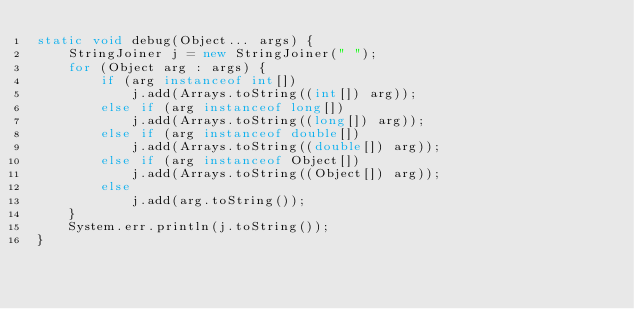Convert code to text. <code><loc_0><loc_0><loc_500><loc_500><_Java_>static void debug(Object... args) {
    StringJoiner j = new StringJoiner(" ");
    for (Object arg : args) {
        if (arg instanceof int[])
            j.add(Arrays.toString((int[]) arg));
        else if (arg instanceof long[])
            j.add(Arrays.toString((long[]) arg));
        else if (arg instanceof double[])
            j.add(Arrays.toString((double[]) arg));
        else if (arg instanceof Object[])
            j.add(Arrays.toString((Object[]) arg));
        else
            j.add(arg.toString());
    }
    System.err.println(j.toString());
}</code> 